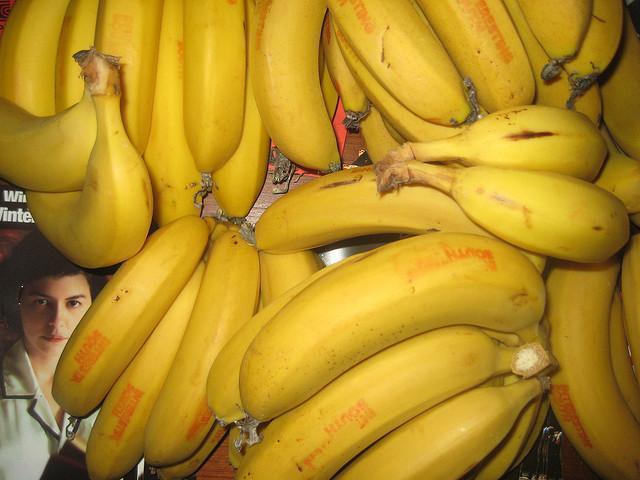How many faces are visible in this photo?
Give a very brief answer. 1. How many bananas are there?
Give a very brief answer. 11. How many people are wearing a tie in the picture?
Give a very brief answer. 0. 